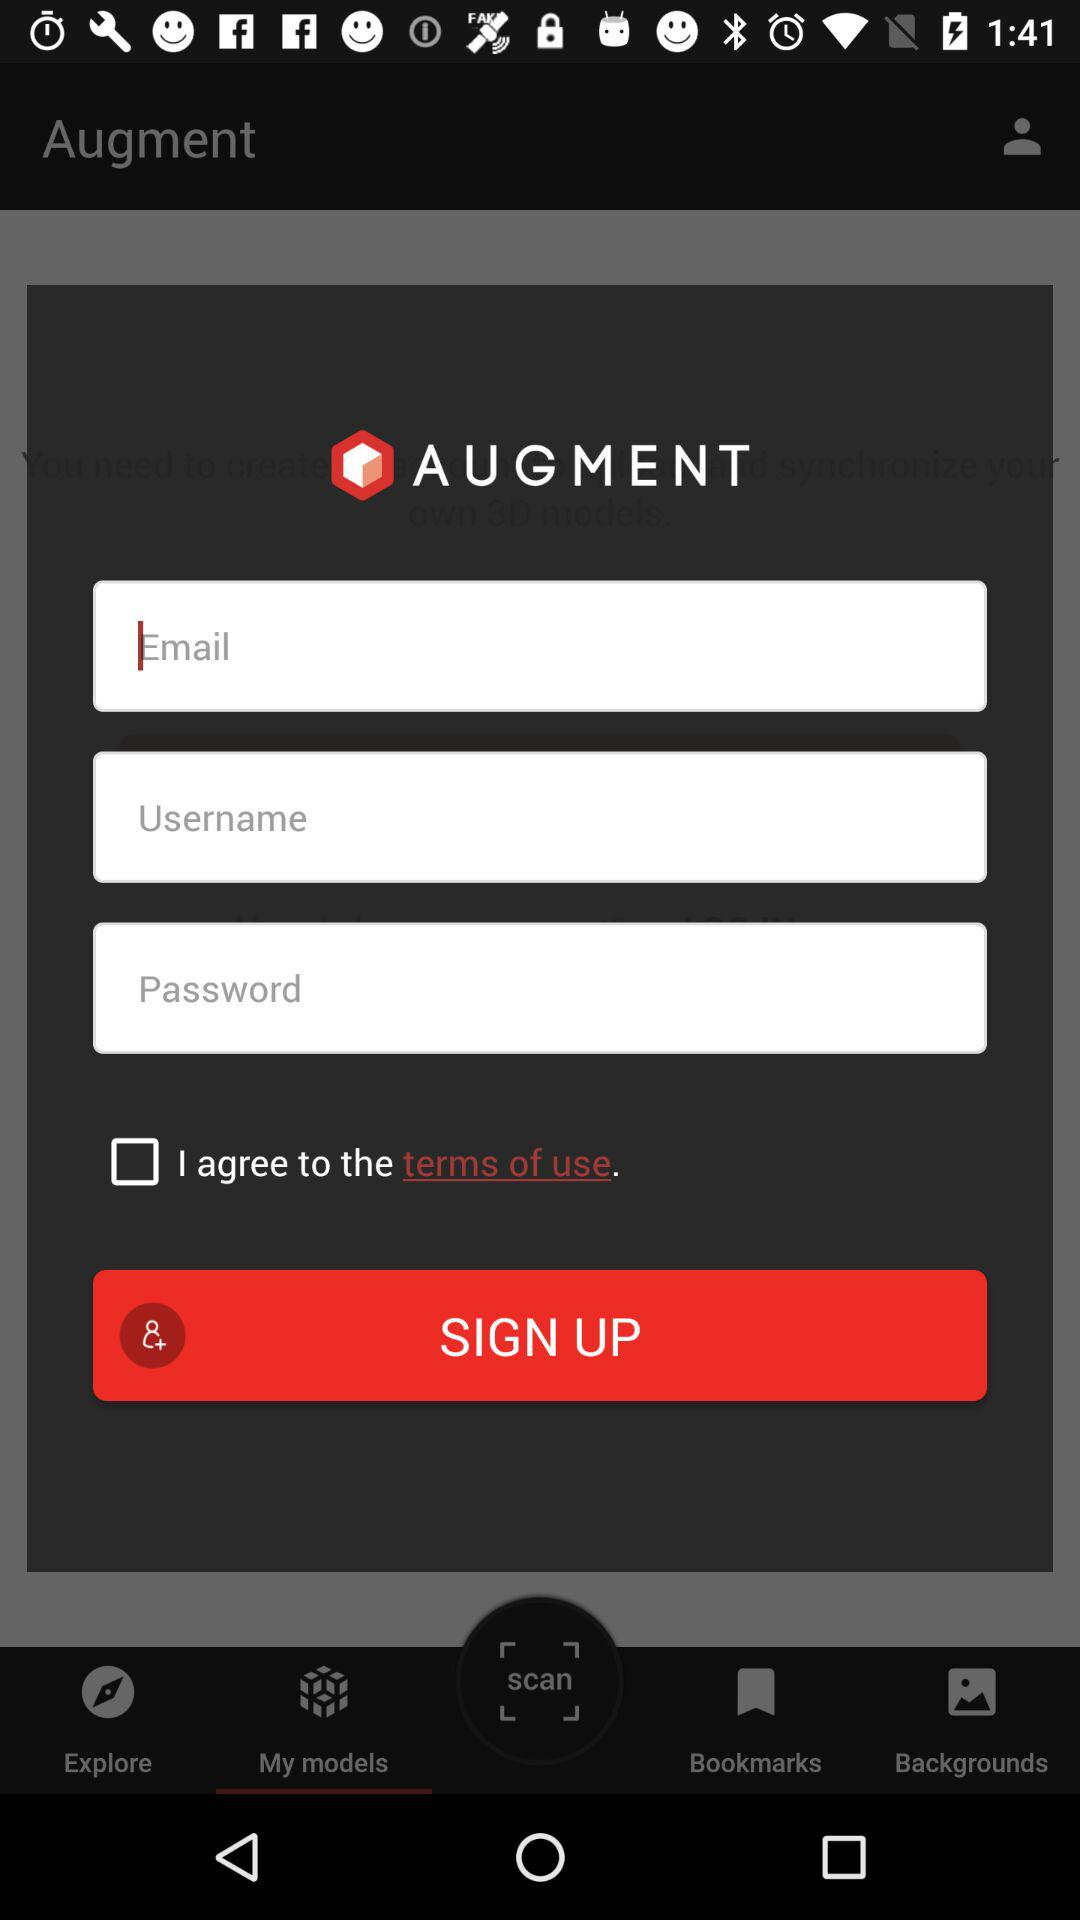What is the status of the option that includes agreement to the "terms of use"? The status is "off". 